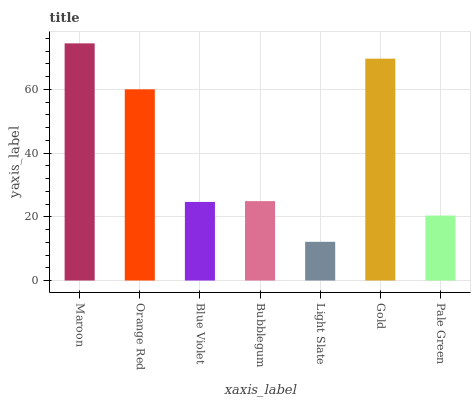Is Light Slate the minimum?
Answer yes or no. Yes. Is Maroon the maximum?
Answer yes or no. Yes. Is Orange Red the minimum?
Answer yes or no. No. Is Orange Red the maximum?
Answer yes or no. No. Is Maroon greater than Orange Red?
Answer yes or no. Yes. Is Orange Red less than Maroon?
Answer yes or no. Yes. Is Orange Red greater than Maroon?
Answer yes or no. No. Is Maroon less than Orange Red?
Answer yes or no. No. Is Bubblegum the high median?
Answer yes or no. Yes. Is Bubblegum the low median?
Answer yes or no. Yes. Is Maroon the high median?
Answer yes or no. No. Is Orange Red the low median?
Answer yes or no. No. 